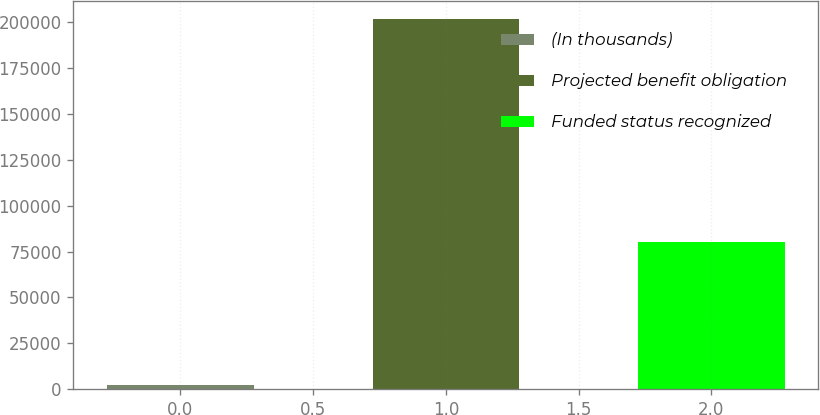Convert chart. <chart><loc_0><loc_0><loc_500><loc_500><bar_chart><fcel>(In thousands)<fcel>Projected benefit obligation<fcel>Funded status recognized<nl><fcel>2016<fcel>201715<fcel>79969<nl></chart> 